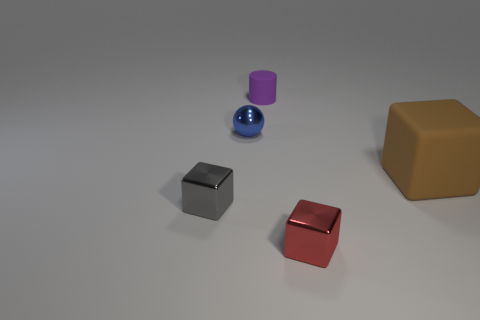The blue metal thing that is the same size as the red metal block is what shape?
Offer a very short reply. Sphere. There is a small cube that is behind the metal block in front of the metal cube behind the small red shiny object; what is it made of?
Give a very brief answer. Metal. Does the matte object that is to the right of the small red block have the same shape as the small metal object in front of the tiny gray object?
Your response must be concise. Yes. How many other objects are there of the same material as the large block?
Give a very brief answer. 1. Are the cube on the right side of the small red shiny thing and the small object behind the tiny blue metal object made of the same material?
Ensure brevity in your answer.  Yes. There is a object that is the same material as the cylinder; what is its shape?
Your answer should be compact. Cube. Is there any other thing of the same color as the small rubber thing?
Provide a succinct answer. No. How many large brown cylinders are there?
Provide a short and direct response. 0. The small thing that is left of the purple rubber thing and in front of the small blue ball has what shape?
Provide a succinct answer. Cube. The rubber object that is on the left side of the tiny metallic block to the right of the rubber object that is on the left side of the big brown object is what shape?
Your answer should be very brief. Cylinder. 